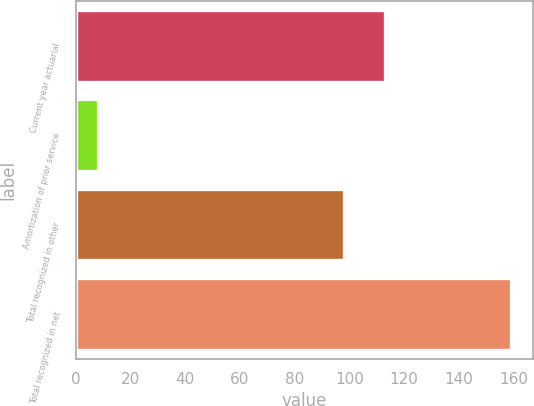Convert chart to OTSL. <chart><loc_0><loc_0><loc_500><loc_500><bar_chart><fcel>Current year actuarial<fcel>Amortization of prior service<fcel>Total recognized in other<fcel>Total recognized in net<nl><fcel>113.1<fcel>8<fcel>98<fcel>159<nl></chart> 